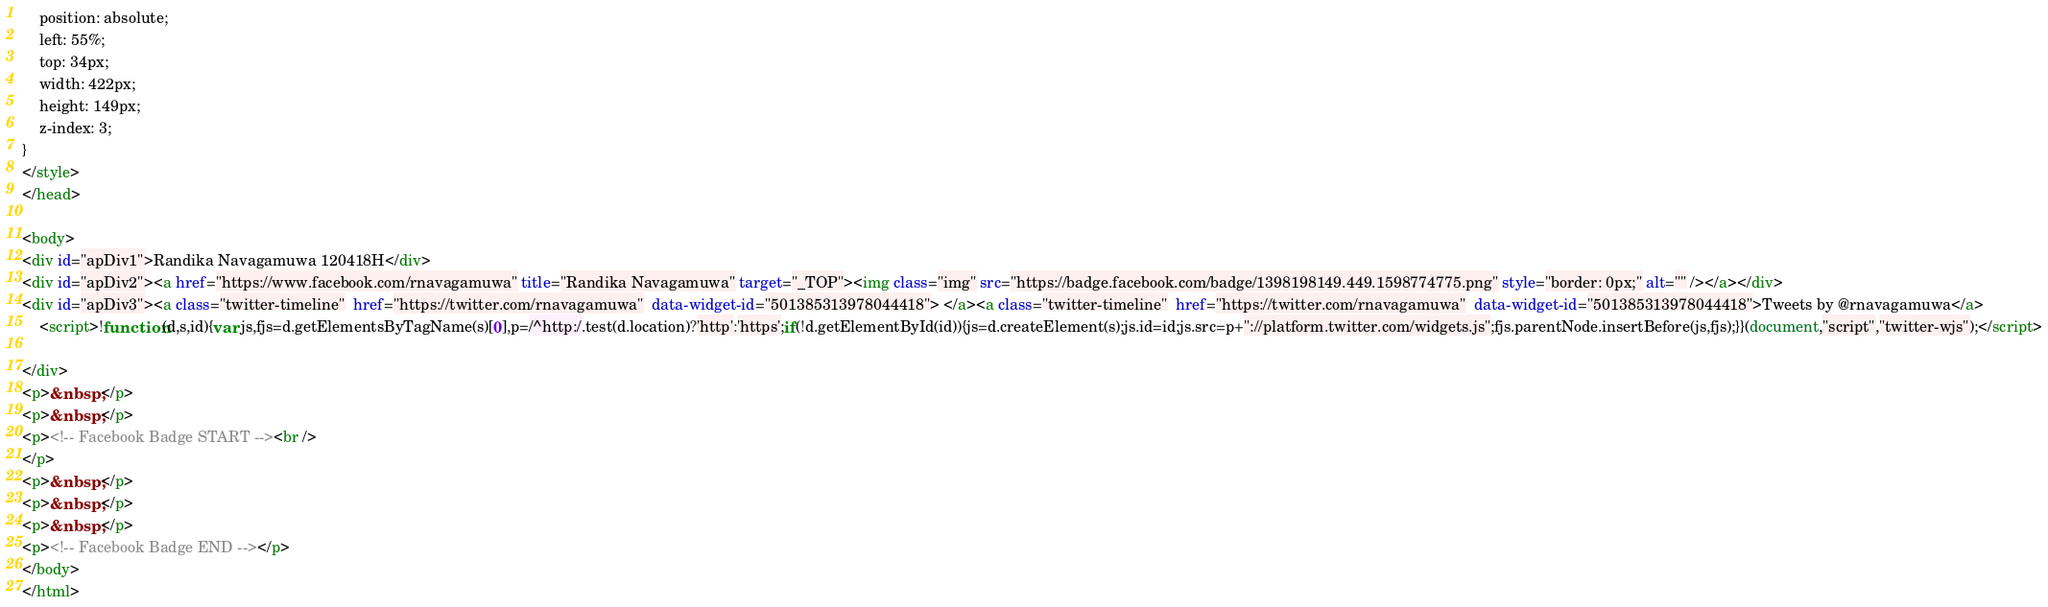<code> <loc_0><loc_0><loc_500><loc_500><_HTML_>	position: absolute;
	left: 55%;
	top: 34px;
	width: 422px;
	height: 149px;
	z-index: 3;
}
</style>
</head>

<body>
<div id="apDiv1">Randika Navagamuwa 120418H</div>
<div id="apDiv2"><a href="https://www.facebook.com/rnavagamuwa" title="Randika Navagamuwa" target="_TOP"><img class="img" src="https://badge.facebook.com/badge/1398198149.449.1598774775.png" style="border: 0px;" alt="" /></a></div>
<div id="apDiv3"><a class="twitter-timeline"  href="https://twitter.com/rnavagamuwa"  data-widget-id="501385313978044418"> </a><a class="twitter-timeline"  href="https://twitter.com/rnavagamuwa"  data-widget-id="501385313978044418">Tweets by @rnavagamuwa</a>
    <script>!function(d,s,id){var js,fjs=d.getElementsByTagName(s)[0],p=/^http:/.test(d.location)?'http':'https';if(!d.getElementById(id)){js=d.createElement(s);js.id=id;js.src=p+"://platform.twitter.com/widgets.js";fjs.parentNode.insertBefore(js,fjs);}}(document,"script","twitter-wjs");</script>

</div>
<p>&nbsp;</p>
<p>&nbsp;</p>
<p><!-- Facebook Badge START --><br />
</p>
<p>&nbsp;</p>
<p>&nbsp;</p>
<p>&nbsp;</p>
<p><!-- Facebook Badge END --></p>
</body>
</html>
</code> 